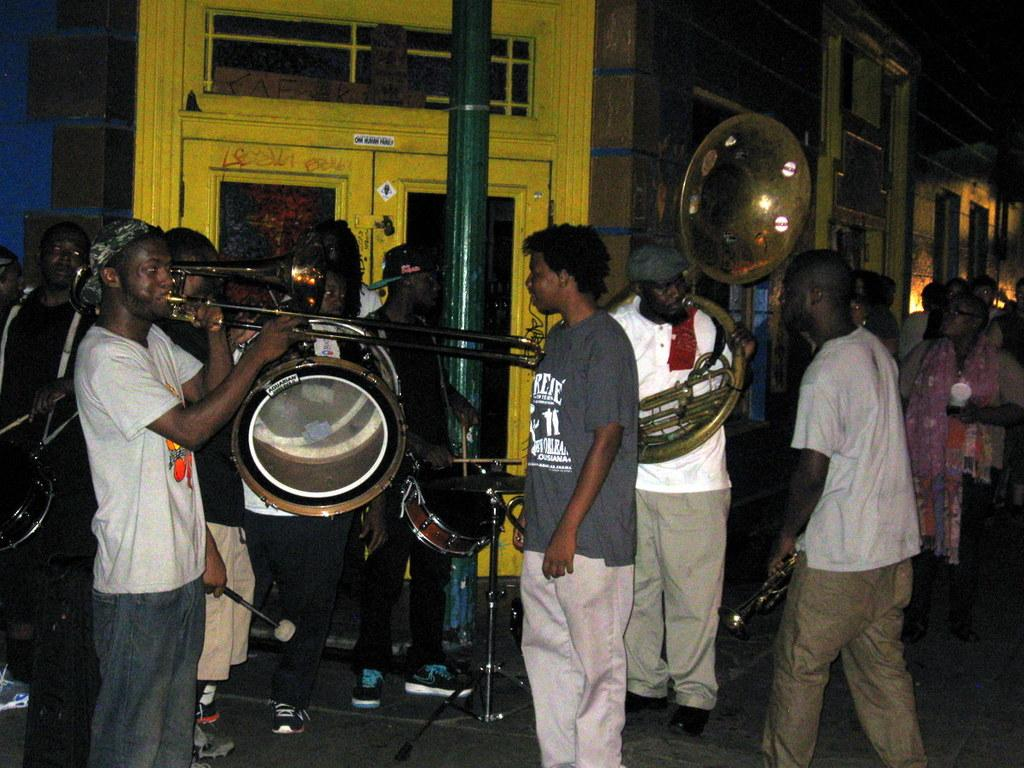What are the people in the image doing? The group of people are holding musical instruments and playing them. What can be seen in the background of the image? There are buildings and a pole in the background of the image. What is at the bottom of the image? There is a walkway at the bottom of the image. What shape is the reward given to the musicians in the image? There is no reward present in the image, and therefore no shape can be determined. 